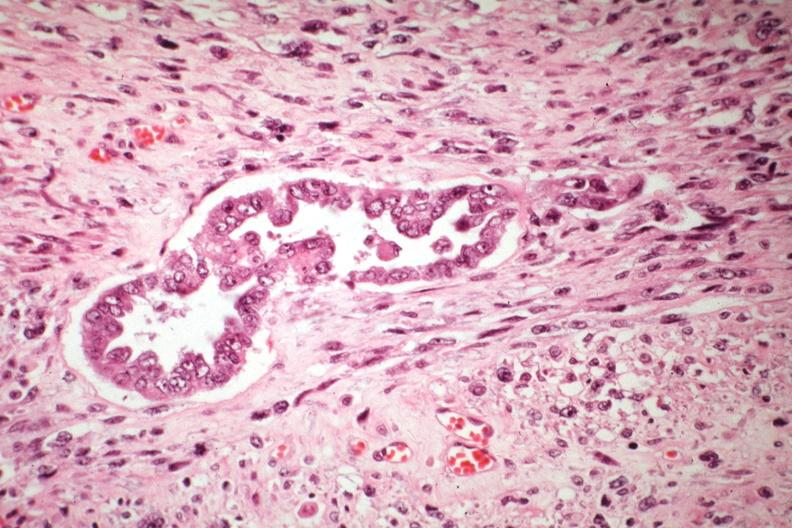s mixed mesodermal tumor present?
Answer the question using a single word or phrase. Yes 